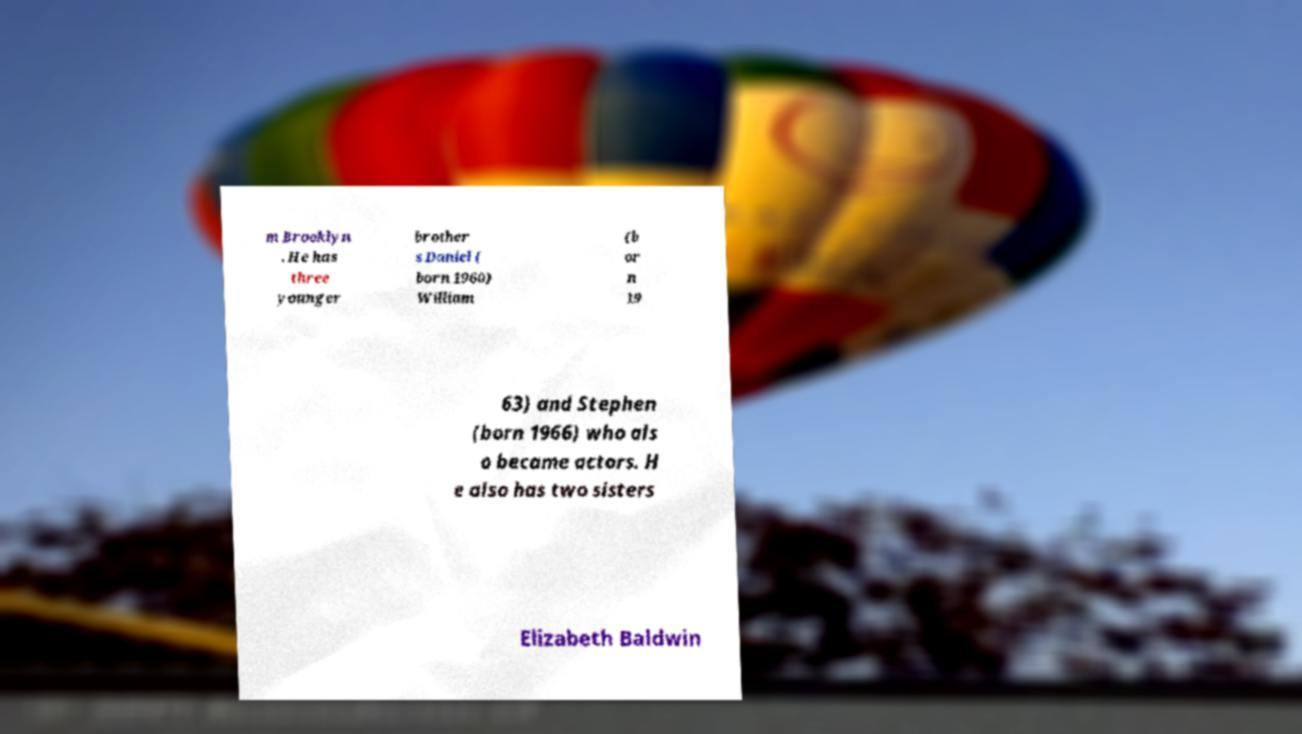Could you extract and type out the text from this image? m Brooklyn . He has three younger brother s Daniel ( born 1960) William (b or n 19 63) and Stephen (born 1966) who als o became actors. H e also has two sisters Elizabeth Baldwin 